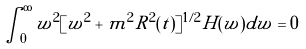<formula> <loc_0><loc_0><loc_500><loc_500>\int _ { 0 } ^ { \infty } w ^ { 2 } [ w ^ { 2 } + m ^ { 2 } R ^ { 2 } ( t ) ] ^ { 1 / 2 } H ( w ) d w = 0</formula> 